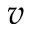Convert formula to latex. <formula><loc_0><loc_0><loc_500><loc_500>v</formula> 